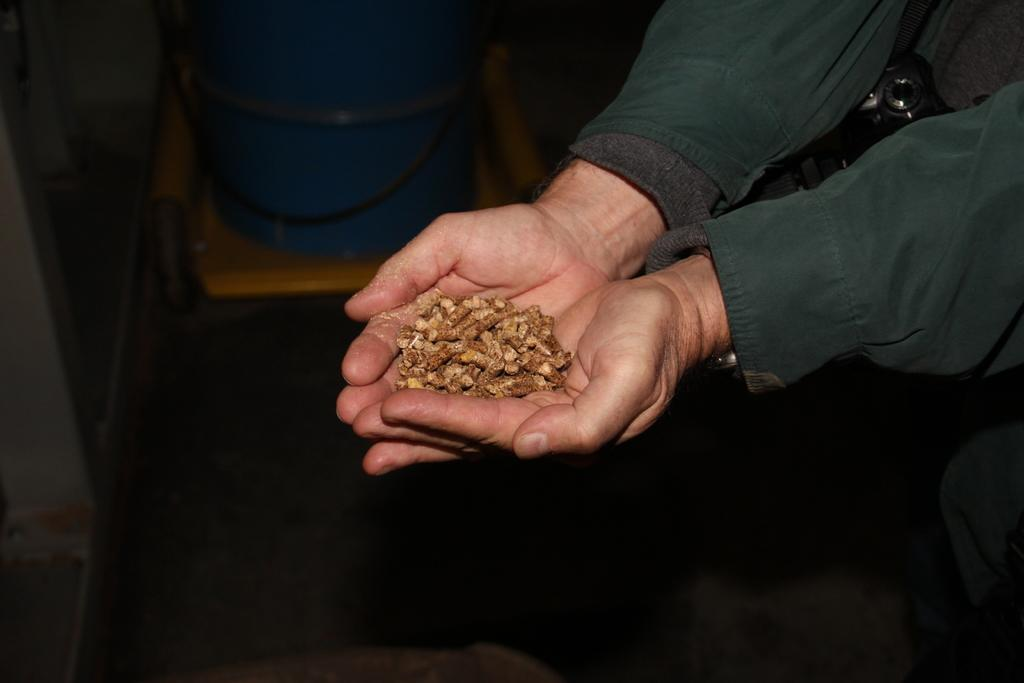Who is present in the image? There is a person in the image. What is the person wearing? The person is wearing a green dress. What is the person holding in the image? The person is holding dog food. What object can be seen on a table in the image? There is a bucket on a table in the image. How many pizzas are being delivered by the person in the image? There are no pizzas present in the image, and the person is not delivering anything. 